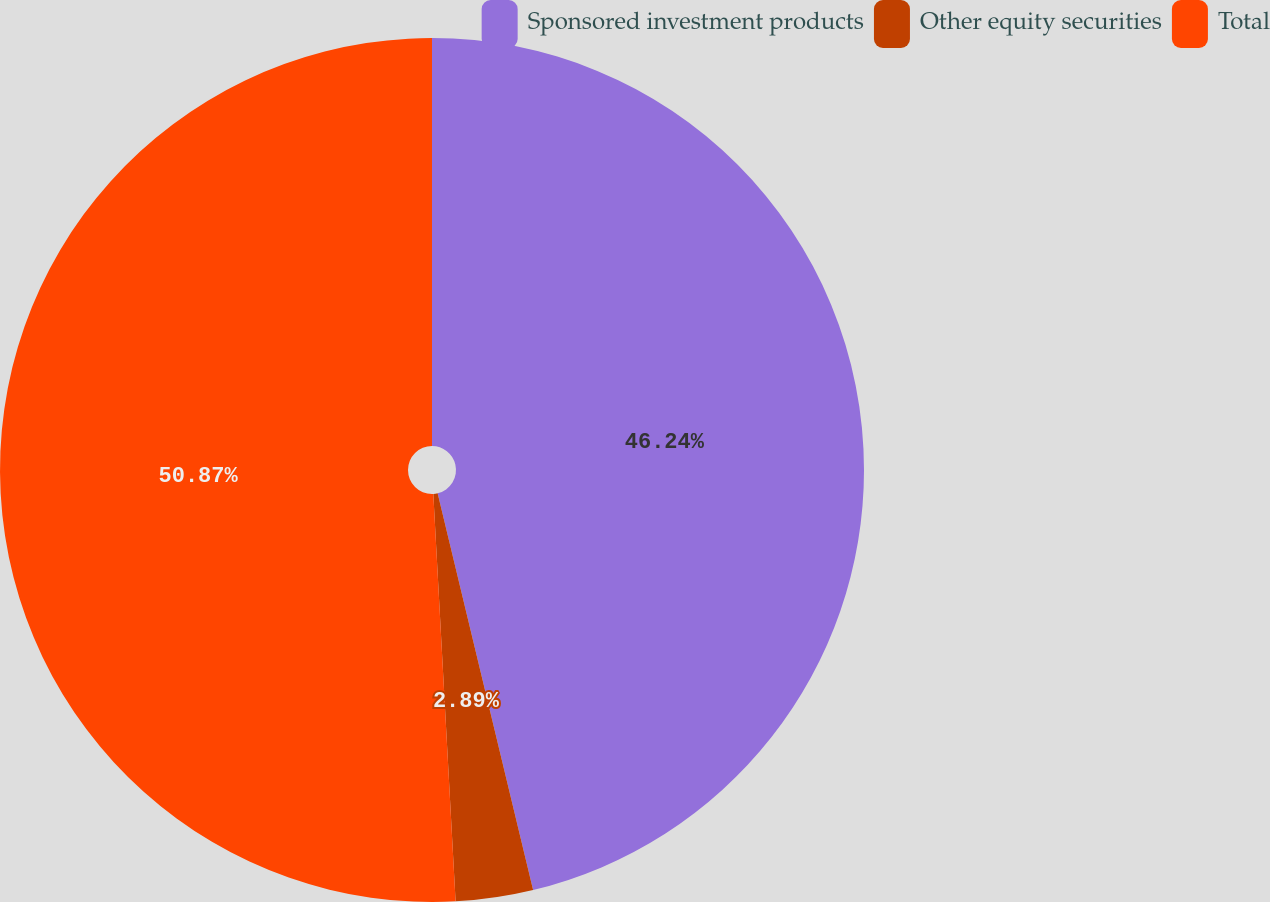Convert chart to OTSL. <chart><loc_0><loc_0><loc_500><loc_500><pie_chart><fcel>Sponsored investment products<fcel>Other equity securities<fcel>Total<nl><fcel>46.24%<fcel>2.89%<fcel>50.87%<nl></chart> 